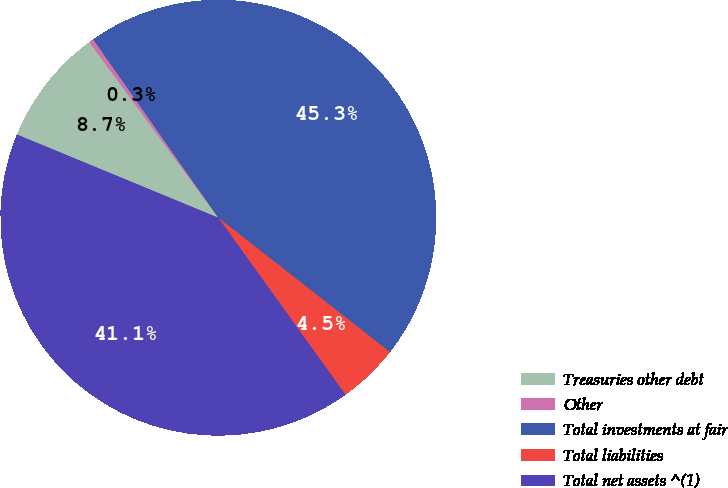Convert chart. <chart><loc_0><loc_0><loc_500><loc_500><pie_chart><fcel>Treasuries other debt<fcel>Other<fcel>Total investments at fair<fcel>Total liabilities<fcel>Total net assets ^(1)<nl><fcel>8.68%<fcel>0.35%<fcel>45.31%<fcel>4.51%<fcel>41.15%<nl></chart> 